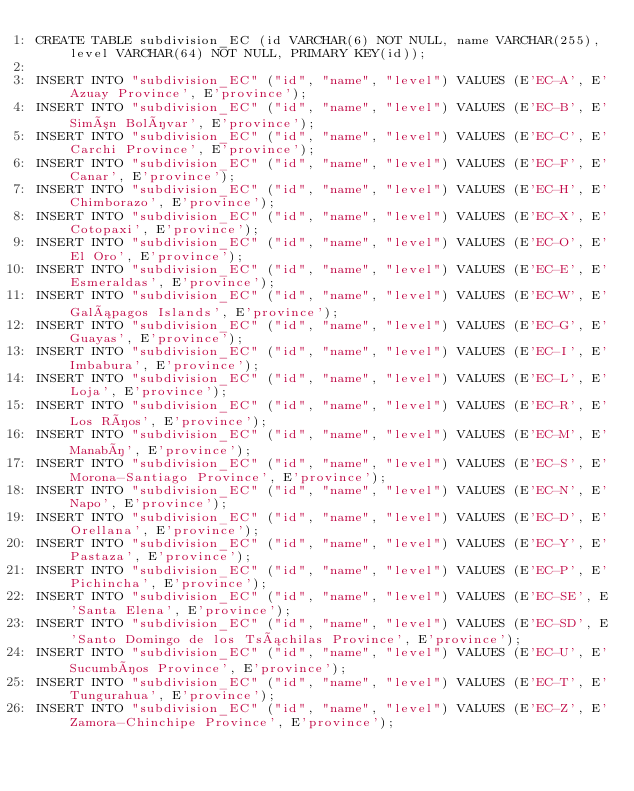Convert code to text. <code><loc_0><loc_0><loc_500><loc_500><_SQL_>CREATE TABLE subdivision_EC (id VARCHAR(6) NOT NULL, name VARCHAR(255), level VARCHAR(64) NOT NULL, PRIMARY KEY(id));

INSERT INTO "subdivision_EC" ("id", "name", "level") VALUES (E'EC-A', E'Azuay Province', E'province');
INSERT INTO "subdivision_EC" ("id", "name", "level") VALUES (E'EC-B', E'Simón Bolívar', E'province');
INSERT INTO "subdivision_EC" ("id", "name", "level") VALUES (E'EC-C', E'Carchi Province', E'province');
INSERT INTO "subdivision_EC" ("id", "name", "level") VALUES (E'EC-F', E'Canar', E'province');
INSERT INTO "subdivision_EC" ("id", "name", "level") VALUES (E'EC-H', E'Chimborazo', E'province');
INSERT INTO "subdivision_EC" ("id", "name", "level") VALUES (E'EC-X', E'Cotopaxi', E'province');
INSERT INTO "subdivision_EC" ("id", "name", "level") VALUES (E'EC-O', E'El Oro', E'province');
INSERT INTO "subdivision_EC" ("id", "name", "level") VALUES (E'EC-E', E'Esmeraldas', E'province');
INSERT INTO "subdivision_EC" ("id", "name", "level") VALUES (E'EC-W', E'Galápagos Islands', E'province');
INSERT INTO "subdivision_EC" ("id", "name", "level") VALUES (E'EC-G', E'Guayas', E'province');
INSERT INTO "subdivision_EC" ("id", "name", "level") VALUES (E'EC-I', E'Imbabura', E'province');
INSERT INTO "subdivision_EC" ("id", "name", "level") VALUES (E'EC-L', E'Loja', E'province');
INSERT INTO "subdivision_EC" ("id", "name", "level") VALUES (E'EC-R', E'Los Ríos', E'province');
INSERT INTO "subdivision_EC" ("id", "name", "level") VALUES (E'EC-M', E'Manabí', E'province');
INSERT INTO "subdivision_EC" ("id", "name", "level") VALUES (E'EC-S', E'Morona-Santiago Province', E'province');
INSERT INTO "subdivision_EC" ("id", "name", "level") VALUES (E'EC-N', E'Napo', E'province');
INSERT INTO "subdivision_EC" ("id", "name", "level") VALUES (E'EC-D', E'Orellana', E'province');
INSERT INTO "subdivision_EC" ("id", "name", "level") VALUES (E'EC-Y', E'Pastaza', E'province');
INSERT INTO "subdivision_EC" ("id", "name", "level") VALUES (E'EC-P', E'Pichincha', E'province');
INSERT INTO "subdivision_EC" ("id", "name", "level") VALUES (E'EC-SE', E'Santa Elena', E'province');
INSERT INTO "subdivision_EC" ("id", "name", "level") VALUES (E'EC-SD', E'Santo Domingo de los Tsáchilas Province', E'province');
INSERT INTO "subdivision_EC" ("id", "name", "level") VALUES (E'EC-U', E'Sucumbíos Province', E'province');
INSERT INTO "subdivision_EC" ("id", "name", "level") VALUES (E'EC-T', E'Tungurahua', E'province');
INSERT INTO "subdivision_EC" ("id", "name", "level") VALUES (E'EC-Z', E'Zamora-Chinchipe Province', E'province');
</code> 